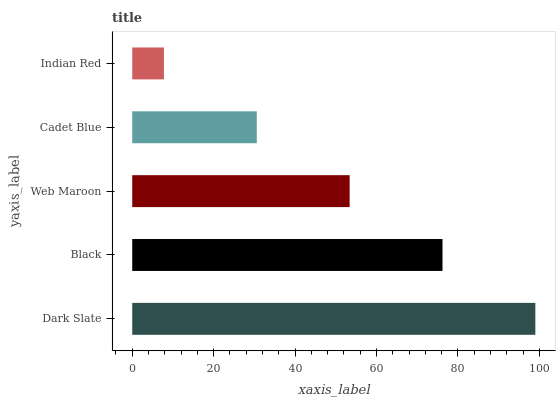Is Indian Red the minimum?
Answer yes or no. Yes. Is Dark Slate the maximum?
Answer yes or no. Yes. Is Black the minimum?
Answer yes or no. No. Is Black the maximum?
Answer yes or no. No. Is Dark Slate greater than Black?
Answer yes or no. Yes. Is Black less than Dark Slate?
Answer yes or no. Yes. Is Black greater than Dark Slate?
Answer yes or no. No. Is Dark Slate less than Black?
Answer yes or no. No. Is Web Maroon the high median?
Answer yes or no. Yes. Is Web Maroon the low median?
Answer yes or no. Yes. Is Indian Red the high median?
Answer yes or no. No. Is Cadet Blue the low median?
Answer yes or no. No. 